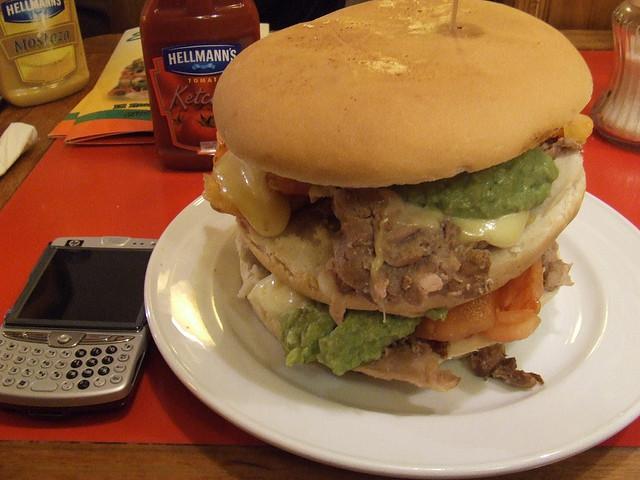Is this sandwich fattening?
Be succinct. Yes. Is there bacon on the burger?
Short answer required. No. Where are the sesame seeds?
Write a very short answer. None. Should the diner look out for a toothpick?
Keep it brief. Yes. How big is the burger?
Give a very brief answer. Huge. 